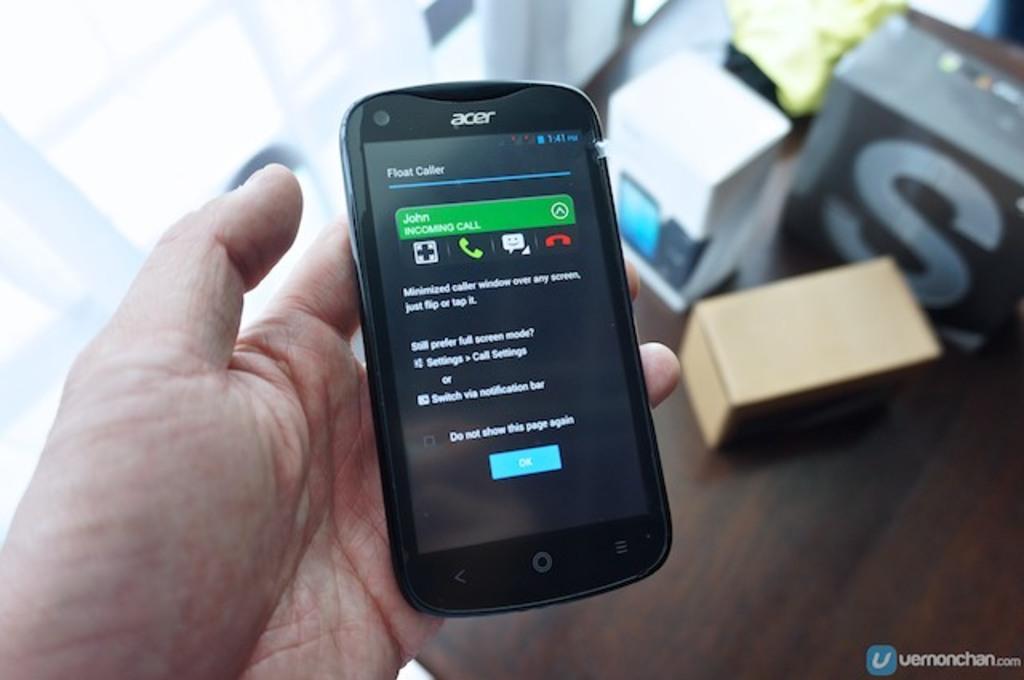What kind of phone is this?
Provide a short and direct response. Acer. What does the phone screen say?
Keep it short and to the point. John incoming call. 